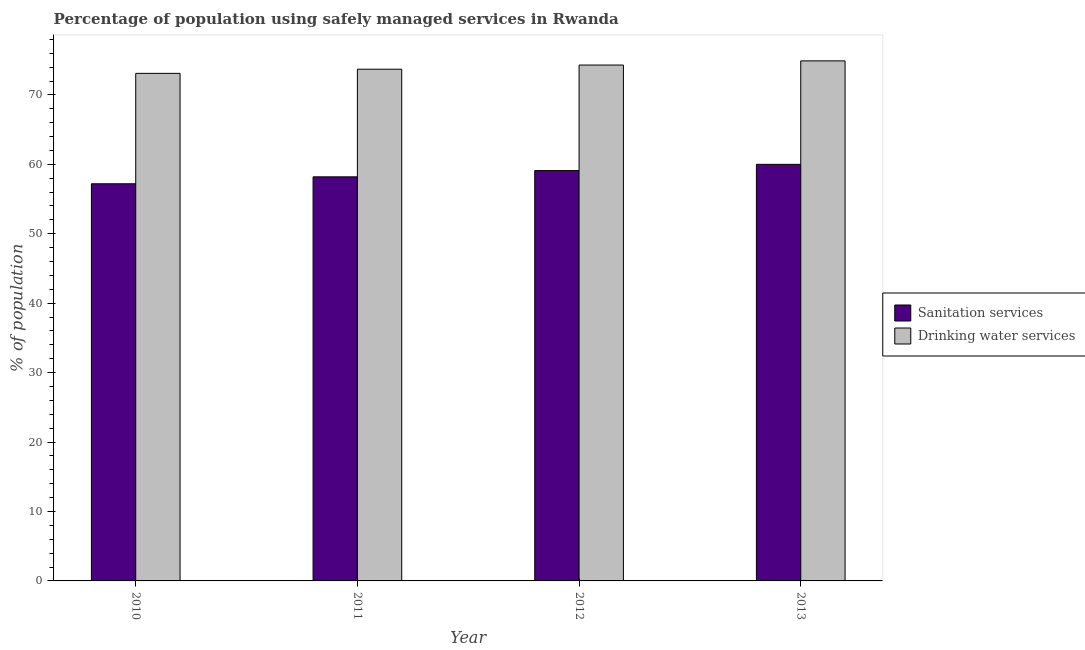How many bars are there on the 1st tick from the left?
Keep it short and to the point. 2. How many bars are there on the 4th tick from the right?
Offer a very short reply. 2. What is the label of the 1st group of bars from the left?
Offer a terse response. 2010. In how many cases, is the number of bars for a given year not equal to the number of legend labels?
Give a very brief answer. 0. What is the percentage of population who used sanitation services in 2010?
Provide a succinct answer. 57.2. Across all years, what is the maximum percentage of population who used drinking water services?
Offer a very short reply. 74.9. Across all years, what is the minimum percentage of population who used sanitation services?
Keep it short and to the point. 57.2. What is the total percentage of population who used drinking water services in the graph?
Keep it short and to the point. 296. What is the difference between the percentage of population who used drinking water services in 2011 and that in 2012?
Your response must be concise. -0.6. What is the difference between the percentage of population who used sanitation services in 2013 and the percentage of population who used drinking water services in 2010?
Offer a very short reply. 2.8. What is the average percentage of population who used sanitation services per year?
Your answer should be compact. 58.62. In the year 2011, what is the difference between the percentage of population who used sanitation services and percentage of population who used drinking water services?
Your response must be concise. 0. What is the ratio of the percentage of population who used sanitation services in 2011 to that in 2013?
Offer a very short reply. 0.97. Is the percentage of population who used sanitation services in 2010 less than that in 2013?
Your response must be concise. Yes. Is the difference between the percentage of population who used sanitation services in 2010 and 2011 greater than the difference between the percentage of population who used drinking water services in 2010 and 2011?
Keep it short and to the point. No. What is the difference between the highest and the second highest percentage of population who used drinking water services?
Provide a short and direct response. 0.6. What is the difference between the highest and the lowest percentage of population who used sanitation services?
Provide a succinct answer. 2.8. What does the 2nd bar from the left in 2010 represents?
Your answer should be compact. Drinking water services. What does the 2nd bar from the right in 2010 represents?
Ensure brevity in your answer.  Sanitation services. Are all the bars in the graph horizontal?
Give a very brief answer. No. What is the difference between two consecutive major ticks on the Y-axis?
Offer a very short reply. 10. Does the graph contain any zero values?
Ensure brevity in your answer.  No. Does the graph contain grids?
Offer a very short reply. No. Where does the legend appear in the graph?
Give a very brief answer. Center right. How are the legend labels stacked?
Ensure brevity in your answer.  Vertical. What is the title of the graph?
Offer a terse response. Percentage of population using safely managed services in Rwanda. What is the label or title of the X-axis?
Offer a terse response. Year. What is the label or title of the Y-axis?
Your answer should be compact. % of population. What is the % of population in Sanitation services in 2010?
Make the answer very short. 57.2. What is the % of population of Drinking water services in 2010?
Keep it short and to the point. 73.1. What is the % of population in Sanitation services in 2011?
Provide a succinct answer. 58.2. What is the % of population in Drinking water services in 2011?
Ensure brevity in your answer.  73.7. What is the % of population of Sanitation services in 2012?
Offer a very short reply. 59.1. What is the % of population of Drinking water services in 2012?
Make the answer very short. 74.3. What is the % of population in Drinking water services in 2013?
Make the answer very short. 74.9. Across all years, what is the maximum % of population of Sanitation services?
Your answer should be compact. 60. Across all years, what is the maximum % of population in Drinking water services?
Provide a succinct answer. 74.9. Across all years, what is the minimum % of population of Sanitation services?
Provide a succinct answer. 57.2. Across all years, what is the minimum % of population of Drinking water services?
Provide a short and direct response. 73.1. What is the total % of population of Sanitation services in the graph?
Give a very brief answer. 234.5. What is the total % of population in Drinking water services in the graph?
Your response must be concise. 296. What is the difference between the % of population in Sanitation services in 2010 and that in 2012?
Offer a terse response. -1.9. What is the difference between the % of population of Drinking water services in 2010 and that in 2012?
Your response must be concise. -1.2. What is the difference between the % of population of Sanitation services in 2010 and that in 2013?
Your response must be concise. -2.8. What is the difference between the % of population of Drinking water services in 2011 and that in 2012?
Your answer should be very brief. -0.6. What is the difference between the % of population in Sanitation services in 2012 and that in 2013?
Your answer should be very brief. -0.9. What is the difference between the % of population in Sanitation services in 2010 and the % of population in Drinking water services in 2011?
Offer a terse response. -16.5. What is the difference between the % of population in Sanitation services in 2010 and the % of population in Drinking water services in 2012?
Your answer should be compact. -17.1. What is the difference between the % of population in Sanitation services in 2010 and the % of population in Drinking water services in 2013?
Give a very brief answer. -17.7. What is the difference between the % of population in Sanitation services in 2011 and the % of population in Drinking water services in 2012?
Provide a succinct answer. -16.1. What is the difference between the % of population of Sanitation services in 2011 and the % of population of Drinking water services in 2013?
Give a very brief answer. -16.7. What is the difference between the % of population in Sanitation services in 2012 and the % of population in Drinking water services in 2013?
Ensure brevity in your answer.  -15.8. What is the average % of population in Sanitation services per year?
Offer a terse response. 58.62. What is the average % of population in Drinking water services per year?
Offer a terse response. 74. In the year 2010, what is the difference between the % of population of Sanitation services and % of population of Drinking water services?
Your response must be concise. -15.9. In the year 2011, what is the difference between the % of population of Sanitation services and % of population of Drinking water services?
Offer a very short reply. -15.5. In the year 2012, what is the difference between the % of population of Sanitation services and % of population of Drinking water services?
Offer a very short reply. -15.2. In the year 2013, what is the difference between the % of population of Sanitation services and % of population of Drinking water services?
Give a very brief answer. -14.9. What is the ratio of the % of population in Sanitation services in 2010 to that in 2011?
Offer a terse response. 0.98. What is the ratio of the % of population of Sanitation services in 2010 to that in 2012?
Offer a terse response. 0.97. What is the ratio of the % of population of Drinking water services in 2010 to that in 2012?
Keep it short and to the point. 0.98. What is the ratio of the % of population in Sanitation services in 2010 to that in 2013?
Keep it short and to the point. 0.95. What is the ratio of the % of population in Drinking water services in 2010 to that in 2013?
Keep it short and to the point. 0.98. What is the ratio of the % of population of Drinking water services in 2011 to that in 2013?
Offer a very short reply. 0.98. What is the ratio of the % of population of Sanitation services in 2012 to that in 2013?
Your answer should be very brief. 0.98. What is the ratio of the % of population in Drinking water services in 2012 to that in 2013?
Your response must be concise. 0.99. What is the difference between the highest and the second highest % of population in Drinking water services?
Offer a very short reply. 0.6. What is the difference between the highest and the lowest % of population of Sanitation services?
Make the answer very short. 2.8. 